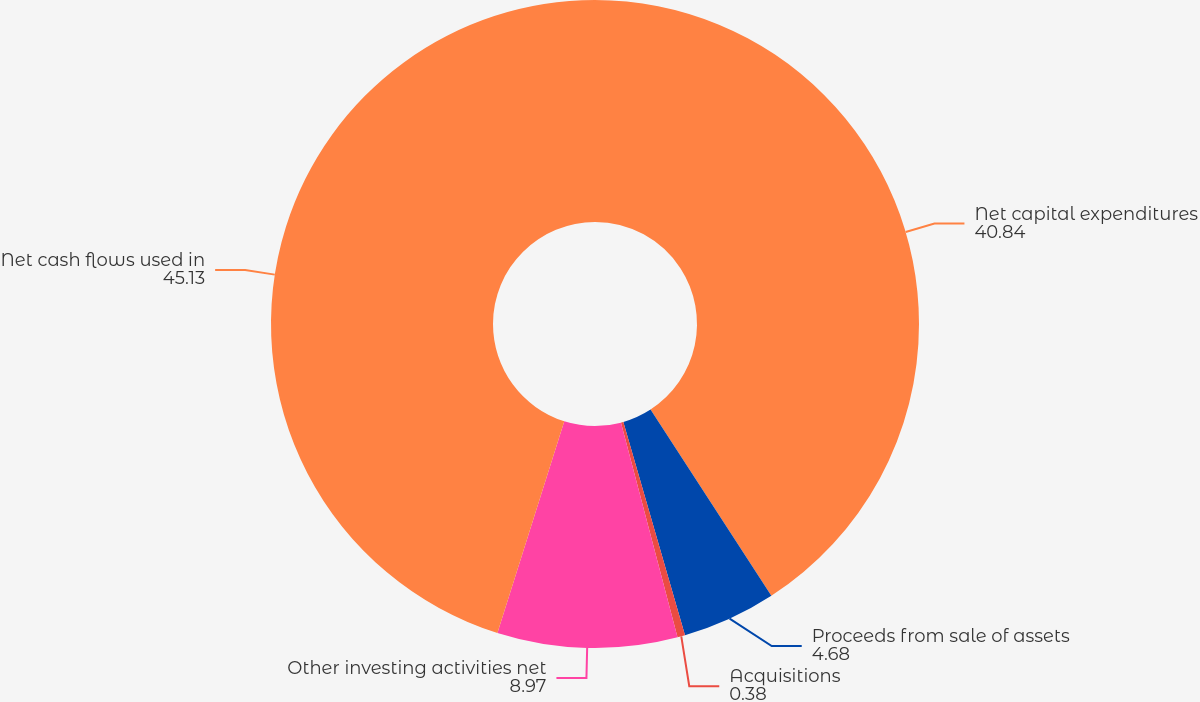Convert chart. <chart><loc_0><loc_0><loc_500><loc_500><pie_chart><fcel>Net capital expenditures<fcel>Proceeds from sale of assets<fcel>Acquisitions<fcel>Other investing activities net<fcel>Net cash flows used in<nl><fcel>40.84%<fcel>4.68%<fcel>0.38%<fcel>8.97%<fcel>45.13%<nl></chart> 